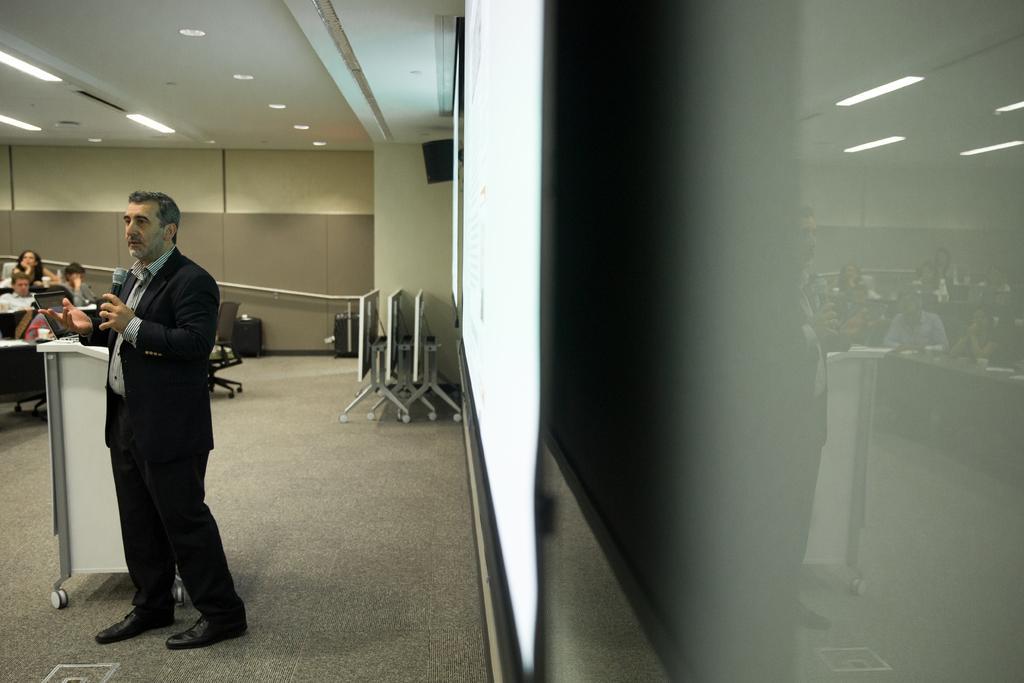Describe this image in one or two sentences. In the foreground of this image, in the middle, there are two screens on the wall. On the left, there is a man standing and holding a mic. Behind him, there is a laptop on a podium. In the background, there are few people sitting in desks. We can also see few boards, chairs, speaker boxes, railing, wall and the lights to the ceiling. 